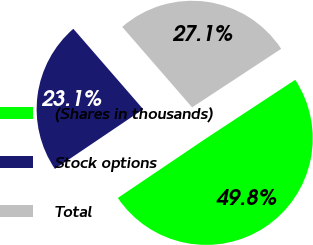Convert chart to OTSL. <chart><loc_0><loc_0><loc_500><loc_500><pie_chart><fcel>(Shares in thousands)<fcel>Stock options<fcel>Total<nl><fcel>49.8%<fcel>23.07%<fcel>27.13%<nl></chart> 